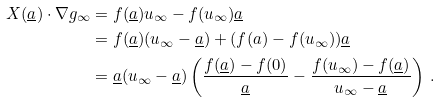Convert formula to latex. <formula><loc_0><loc_0><loc_500><loc_500>X ( \underline { a } ) \cdot \nabla g _ { \infty } & = f ( \underline { a } ) u _ { \infty } - f ( u _ { \infty } ) \underline { a } \\ & = f ( \underline { a } ) ( u _ { \infty } - \underline { a } ) + ( f ( a ) - f ( u _ { \infty } ) ) \underline { a } \\ & = \underline { a } ( u _ { \infty } - \underline { a } ) \left ( \frac { f ( \underline { a } ) - f ( 0 ) } { \underline { a } } - \frac { f ( u _ { \infty } ) - f ( \underline { a } ) } { u _ { \infty } - \underline { a } } \right ) \, .</formula> 